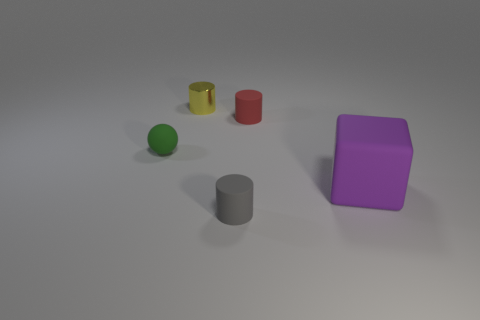Subtract all purple cylinders. Subtract all cyan cubes. How many cylinders are left? 3 Add 3 big cubes. How many objects exist? 8 Subtract all balls. How many objects are left? 4 Subtract all large brown objects. Subtract all purple rubber things. How many objects are left? 4 Add 4 cubes. How many cubes are left? 5 Add 4 tiny yellow shiny cylinders. How many tiny yellow shiny cylinders exist? 5 Subtract 0 blue cubes. How many objects are left? 5 